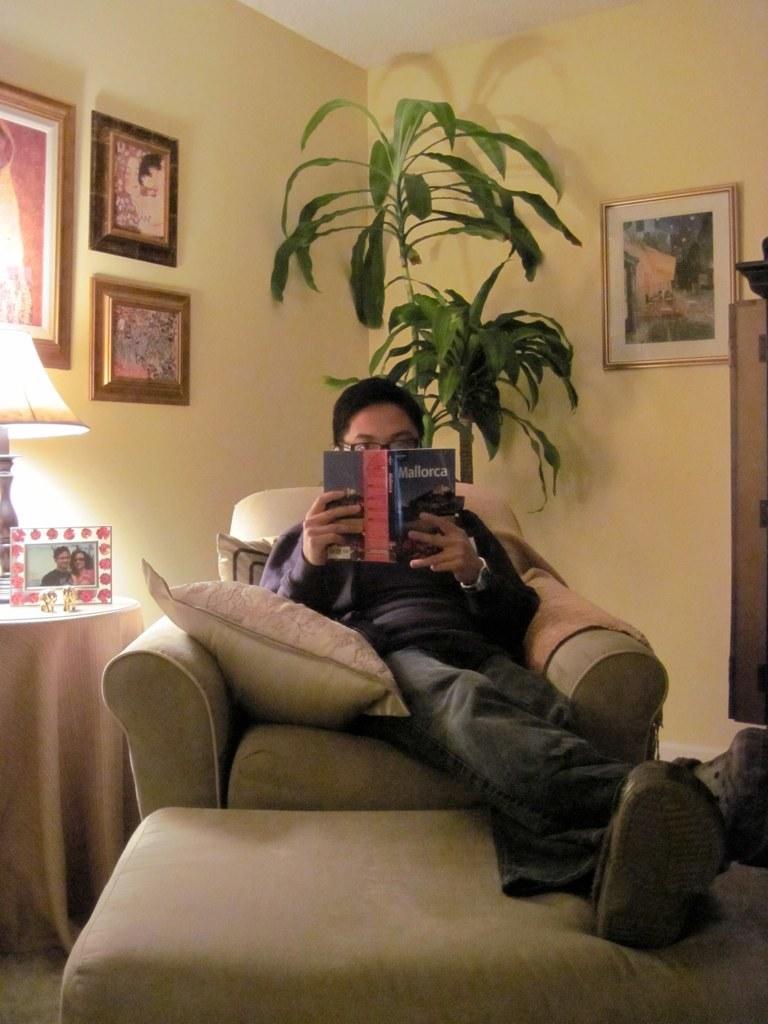Describe this image in one or two sentences. In the middle of the image a man is sitting on a chair and holding a book. Behind him there is a plant. Top right side of the image there is a wall, On the wall there is a frame. Bottom left side of the image there is a table, On the table there is a lamp and photo frame. 